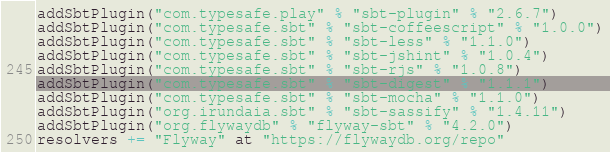Convert code to text. <code><loc_0><loc_0><loc_500><loc_500><_Scala_>addSbtPlugin("com.typesafe.play" % "sbt-plugin" % "2.6.7")
addSbtPlugin("com.typesafe.sbt" % "sbt-coffeescript" % "1.0.0")
addSbtPlugin("com.typesafe.sbt" % "sbt-less" % "1.1.0")
addSbtPlugin("com.typesafe.sbt" % "sbt-jshint" % "1.0.4")
addSbtPlugin("com.typesafe.sbt" % "sbt-rjs" % "1.0.8")
addSbtPlugin("com.typesafe.sbt" % "sbt-digest" % "1.1.1")
addSbtPlugin("com.typesafe.sbt" % "sbt-mocha" % "1.1.0")
addSbtPlugin("org.irundaia.sbt" % "sbt-sassify" % "1.4.11")
addSbtPlugin("org.flywaydb" % "flyway-sbt" % "4.2.0")
resolvers += "Flyway" at "https://flywaydb.org/repo"
</code> 